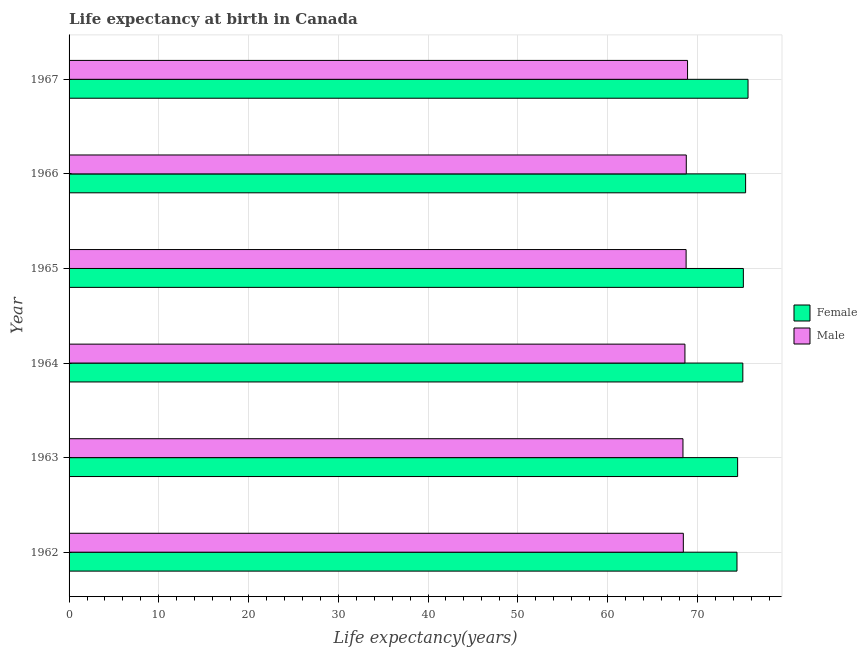Are the number of bars on each tick of the Y-axis equal?
Your answer should be very brief. Yes. How many bars are there on the 1st tick from the top?
Keep it short and to the point. 2. How many bars are there on the 2nd tick from the bottom?
Provide a short and direct response. 2. What is the label of the 6th group of bars from the top?
Your response must be concise. 1962. What is the life expectancy(female) in 1966?
Your answer should be compact. 75.39. Across all years, what is the maximum life expectancy(male)?
Keep it short and to the point. 68.92. Across all years, what is the minimum life expectancy(female)?
Your response must be concise. 74.43. In which year was the life expectancy(female) maximum?
Give a very brief answer. 1967. In which year was the life expectancy(male) minimum?
Provide a succinct answer. 1963. What is the total life expectancy(female) in the graph?
Provide a succinct answer. 450.2. What is the difference between the life expectancy(male) in 1967 and the life expectancy(female) in 1965?
Provide a succinct answer. -6.22. What is the average life expectancy(female) per year?
Give a very brief answer. 75.03. In the year 1964, what is the difference between the life expectancy(male) and life expectancy(female)?
Your answer should be very brief. -6.45. In how many years, is the life expectancy(male) greater than 8 years?
Keep it short and to the point. 6. What is the difference between the highest and the second highest life expectancy(female)?
Give a very brief answer. 0.27. What is the difference between the highest and the lowest life expectancy(male)?
Keep it short and to the point. 0.51. In how many years, is the life expectancy(female) greater than the average life expectancy(female) taken over all years?
Give a very brief answer. 4. What does the 2nd bar from the top in 1964 represents?
Your response must be concise. Female. How many bars are there?
Keep it short and to the point. 12. How many years are there in the graph?
Provide a short and direct response. 6. What is the difference between two consecutive major ticks on the X-axis?
Offer a terse response. 10. Are the values on the major ticks of X-axis written in scientific E-notation?
Your answer should be very brief. No. Does the graph contain any zero values?
Provide a short and direct response. No. How are the legend labels stacked?
Ensure brevity in your answer.  Vertical. What is the title of the graph?
Give a very brief answer. Life expectancy at birth in Canada. Does "Age 65(female)" appear as one of the legend labels in the graph?
Your response must be concise. No. What is the label or title of the X-axis?
Your response must be concise. Life expectancy(years). What is the Life expectancy(years) of Female in 1962?
Your answer should be very brief. 74.43. What is the Life expectancy(years) of Male in 1962?
Your answer should be compact. 68.45. What is the Life expectancy(years) of Female in 1963?
Offer a very short reply. 74.5. What is the Life expectancy(years) in Male in 1963?
Your answer should be compact. 68.41. What is the Life expectancy(years) of Female in 1964?
Your answer should be compact. 75.08. What is the Life expectancy(years) of Male in 1964?
Your answer should be compact. 68.63. What is the Life expectancy(years) of Female in 1965?
Provide a succinct answer. 75.14. What is the Life expectancy(years) in Male in 1965?
Provide a short and direct response. 68.76. What is the Life expectancy(years) of Female in 1966?
Provide a short and direct response. 75.39. What is the Life expectancy(years) of Male in 1966?
Give a very brief answer. 68.78. What is the Life expectancy(years) in Female in 1967?
Give a very brief answer. 75.66. What is the Life expectancy(years) in Male in 1967?
Your response must be concise. 68.92. Across all years, what is the maximum Life expectancy(years) in Female?
Provide a short and direct response. 75.66. Across all years, what is the maximum Life expectancy(years) of Male?
Offer a terse response. 68.92. Across all years, what is the minimum Life expectancy(years) in Female?
Ensure brevity in your answer.  74.43. Across all years, what is the minimum Life expectancy(years) in Male?
Offer a terse response. 68.41. What is the total Life expectancy(years) in Female in the graph?
Provide a short and direct response. 450.2. What is the total Life expectancy(years) of Male in the graph?
Ensure brevity in your answer.  411.95. What is the difference between the Life expectancy(years) in Female in 1962 and that in 1963?
Make the answer very short. -0.07. What is the difference between the Life expectancy(years) in Female in 1962 and that in 1964?
Offer a terse response. -0.65. What is the difference between the Life expectancy(years) in Male in 1962 and that in 1964?
Keep it short and to the point. -0.18. What is the difference between the Life expectancy(years) in Female in 1962 and that in 1965?
Your response must be concise. -0.71. What is the difference between the Life expectancy(years) of Male in 1962 and that in 1965?
Your response must be concise. -0.31. What is the difference between the Life expectancy(years) in Female in 1962 and that in 1966?
Give a very brief answer. -0.96. What is the difference between the Life expectancy(years) of Male in 1962 and that in 1966?
Provide a succinct answer. -0.33. What is the difference between the Life expectancy(years) of Female in 1962 and that in 1967?
Ensure brevity in your answer.  -1.23. What is the difference between the Life expectancy(years) of Male in 1962 and that in 1967?
Offer a terse response. -0.47. What is the difference between the Life expectancy(years) in Female in 1963 and that in 1964?
Offer a very short reply. -0.58. What is the difference between the Life expectancy(years) of Male in 1963 and that in 1964?
Your answer should be compact. -0.22. What is the difference between the Life expectancy(years) of Female in 1963 and that in 1965?
Make the answer very short. -0.64. What is the difference between the Life expectancy(years) of Male in 1963 and that in 1965?
Give a very brief answer. -0.35. What is the difference between the Life expectancy(years) in Female in 1963 and that in 1966?
Ensure brevity in your answer.  -0.89. What is the difference between the Life expectancy(years) in Male in 1963 and that in 1966?
Ensure brevity in your answer.  -0.37. What is the difference between the Life expectancy(years) of Female in 1963 and that in 1967?
Your answer should be very brief. -1.16. What is the difference between the Life expectancy(years) of Male in 1963 and that in 1967?
Offer a terse response. -0.51. What is the difference between the Life expectancy(years) of Female in 1964 and that in 1965?
Keep it short and to the point. -0.06. What is the difference between the Life expectancy(years) in Male in 1964 and that in 1965?
Your answer should be very brief. -0.13. What is the difference between the Life expectancy(years) in Female in 1964 and that in 1966?
Give a very brief answer. -0.31. What is the difference between the Life expectancy(years) in Female in 1964 and that in 1967?
Ensure brevity in your answer.  -0.58. What is the difference between the Life expectancy(years) in Male in 1964 and that in 1967?
Give a very brief answer. -0.29. What is the difference between the Life expectancy(years) of Female in 1965 and that in 1966?
Give a very brief answer. -0.25. What is the difference between the Life expectancy(years) in Male in 1965 and that in 1966?
Your response must be concise. -0.02. What is the difference between the Life expectancy(years) in Female in 1965 and that in 1967?
Provide a succinct answer. -0.52. What is the difference between the Life expectancy(years) in Male in 1965 and that in 1967?
Provide a short and direct response. -0.16. What is the difference between the Life expectancy(years) of Female in 1966 and that in 1967?
Make the answer very short. -0.27. What is the difference between the Life expectancy(years) of Male in 1966 and that in 1967?
Ensure brevity in your answer.  -0.14. What is the difference between the Life expectancy(years) of Female in 1962 and the Life expectancy(years) of Male in 1963?
Provide a short and direct response. 6.02. What is the difference between the Life expectancy(years) of Female in 1962 and the Life expectancy(years) of Male in 1964?
Ensure brevity in your answer.  5.8. What is the difference between the Life expectancy(years) of Female in 1962 and the Life expectancy(years) of Male in 1965?
Your response must be concise. 5.67. What is the difference between the Life expectancy(years) in Female in 1962 and the Life expectancy(years) in Male in 1966?
Your answer should be compact. 5.65. What is the difference between the Life expectancy(years) in Female in 1962 and the Life expectancy(years) in Male in 1967?
Offer a terse response. 5.51. What is the difference between the Life expectancy(years) of Female in 1963 and the Life expectancy(years) of Male in 1964?
Offer a very short reply. 5.87. What is the difference between the Life expectancy(years) in Female in 1963 and the Life expectancy(years) in Male in 1965?
Give a very brief answer. 5.74. What is the difference between the Life expectancy(years) of Female in 1963 and the Life expectancy(years) of Male in 1966?
Your answer should be compact. 5.72. What is the difference between the Life expectancy(years) in Female in 1963 and the Life expectancy(years) in Male in 1967?
Offer a terse response. 5.58. What is the difference between the Life expectancy(years) in Female in 1964 and the Life expectancy(years) in Male in 1965?
Offer a very short reply. 6.32. What is the difference between the Life expectancy(years) in Female in 1964 and the Life expectancy(years) in Male in 1966?
Offer a terse response. 6.3. What is the difference between the Life expectancy(years) in Female in 1964 and the Life expectancy(years) in Male in 1967?
Your response must be concise. 6.16. What is the difference between the Life expectancy(years) in Female in 1965 and the Life expectancy(years) in Male in 1966?
Give a very brief answer. 6.36. What is the difference between the Life expectancy(years) in Female in 1965 and the Life expectancy(years) in Male in 1967?
Offer a very short reply. 6.22. What is the difference between the Life expectancy(years) of Female in 1966 and the Life expectancy(years) of Male in 1967?
Give a very brief answer. 6.47. What is the average Life expectancy(years) of Female per year?
Ensure brevity in your answer.  75.03. What is the average Life expectancy(years) in Male per year?
Your answer should be very brief. 68.66. In the year 1962, what is the difference between the Life expectancy(years) in Female and Life expectancy(years) in Male?
Offer a very short reply. 5.98. In the year 1963, what is the difference between the Life expectancy(years) of Female and Life expectancy(years) of Male?
Your answer should be very brief. 6.09. In the year 1964, what is the difference between the Life expectancy(years) in Female and Life expectancy(years) in Male?
Your answer should be compact. 6.45. In the year 1965, what is the difference between the Life expectancy(years) in Female and Life expectancy(years) in Male?
Provide a succinct answer. 6.38. In the year 1966, what is the difference between the Life expectancy(years) in Female and Life expectancy(years) in Male?
Your answer should be very brief. 6.61. In the year 1967, what is the difference between the Life expectancy(years) of Female and Life expectancy(years) of Male?
Provide a succinct answer. 6.74. What is the ratio of the Life expectancy(years) in Female in 1962 to that in 1964?
Your response must be concise. 0.99. What is the ratio of the Life expectancy(years) in Female in 1962 to that in 1965?
Keep it short and to the point. 0.99. What is the ratio of the Life expectancy(years) in Female in 1962 to that in 1966?
Give a very brief answer. 0.99. What is the ratio of the Life expectancy(years) of Male in 1962 to that in 1966?
Make the answer very short. 1. What is the ratio of the Life expectancy(years) of Female in 1962 to that in 1967?
Ensure brevity in your answer.  0.98. What is the ratio of the Life expectancy(years) of Male in 1963 to that in 1964?
Ensure brevity in your answer.  1. What is the ratio of the Life expectancy(years) in Female in 1963 to that in 1965?
Keep it short and to the point. 0.99. What is the ratio of the Life expectancy(years) of Male in 1963 to that in 1965?
Ensure brevity in your answer.  0.99. What is the ratio of the Life expectancy(years) of Female in 1963 to that in 1966?
Provide a short and direct response. 0.99. What is the ratio of the Life expectancy(years) in Female in 1963 to that in 1967?
Give a very brief answer. 0.98. What is the ratio of the Life expectancy(years) of Male in 1964 to that in 1965?
Give a very brief answer. 1. What is the ratio of the Life expectancy(years) of Male in 1964 to that in 1966?
Your answer should be compact. 1. What is the ratio of the Life expectancy(years) in Female in 1966 to that in 1967?
Offer a terse response. 1. What is the difference between the highest and the second highest Life expectancy(years) in Female?
Offer a very short reply. 0.27. What is the difference between the highest and the second highest Life expectancy(years) of Male?
Your response must be concise. 0.14. What is the difference between the highest and the lowest Life expectancy(years) in Female?
Your answer should be compact. 1.23. What is the difference between the highest and the lowest Life expectancy(years) of Male?
Offer a very short reply. 0.51. 